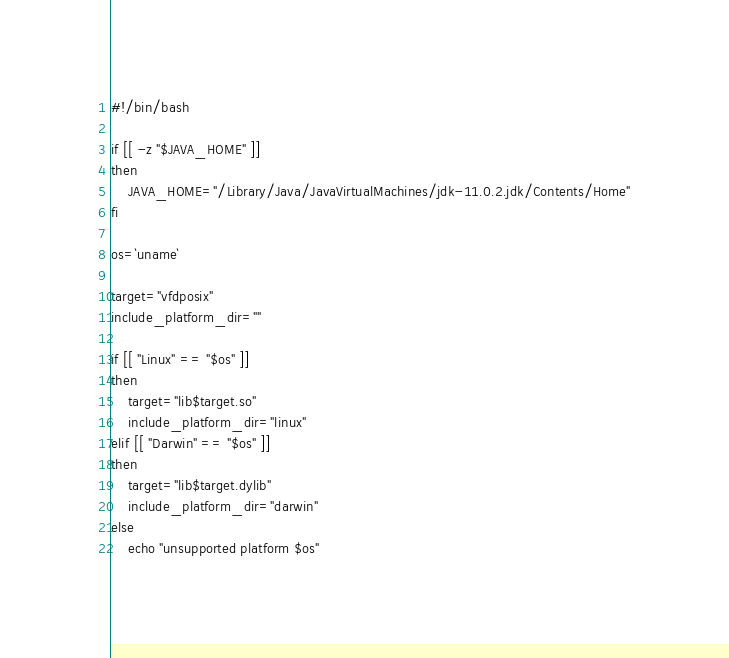Convert code to text. <code><loc_0><loc_0><loc_500><loc_500><_Bash_>#!/bin/bash

if [[ -z "$JAVA_HOME" ]]
then
	JAVA_HOME="/Library/Java/JavaVirtualMachines/jdk-11.0.2.jdk/Contents/Home"
fi

os=`uname`

target="vfdposix"
include_platform_dir=""

if [[ "Linux" == "$os" ]]
then
	target="lib$target.so"
	include_platform_dir="linux"
elif [[ "Darwin" == "$os" ]]
then
	target="lib$target.dylib"
	include_platform_dir="darwin"
else
	echo "unsupported platform $os"</code> 